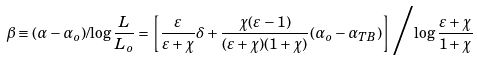<formula> <loc_0><loc_0><loc_500><loc_500>\beta \equiv ( \alpha - \alpha _ { o } ) / { \log { \frac { L } { L _ { o } } } } = \left [ { \frac { \varepsilon } { \varepsilon + \chi } \delta + \frac { \chi ( \varepsilon - 1 ) } { ( \varepsilon + \chi ) ( 1 + \chi ) } ( \alpha _ { o } - \alpha _ { T B } ) } \right ] \Big { / } { \log \frac { \varepsilon + \chi } { 1 + \chi } }</formula> 